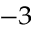Convert formula to latex. <formula><loc_0><loc_0><loc_500><loc_500>^ { - 3 }</formula> 